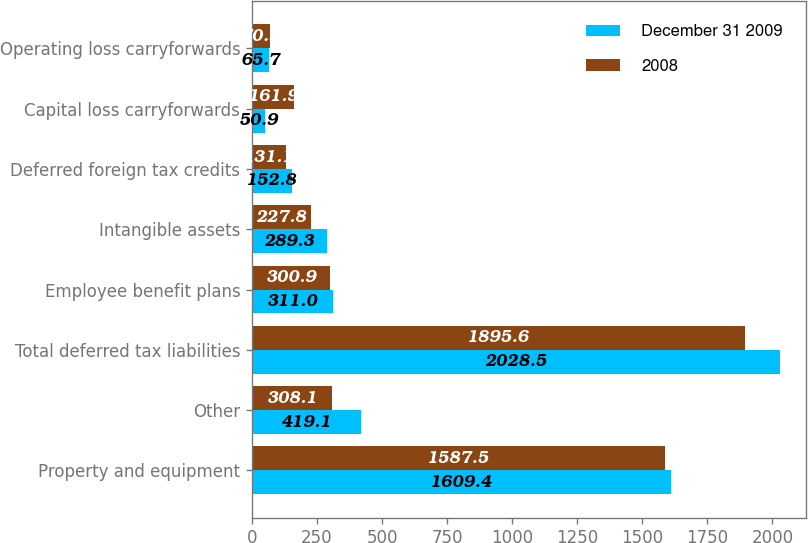Convert chart to OTSL. <chart><loc_0><loc_0><loc_500><loc_500><stacked_bar_chart><ecel><fcel>Property and equipment<fcel>Other<fcel>Total deferred tax liabilities<fcel>Employee benefit plans<fcel>Intangible assets<fcel>Deferred foreign tax credits<fcel>Capital loss carryforwards<fcel>Operating loss carryforwards<nl><fcel>December 31 2009<fcel>1609.4<fcel>419.1<fcel>2028.5<fcel>311<fcel>289.3<fcel>152.8<fcel>50.9<fcel>65.7<nl><fcel>2008<fcel>1587.5<fcel>308.1<fcel>1895.6<fcel>300.9<fcel>227.8<fcel>131.1<fcel>161.9<fcel>70.9<nl></chart> 